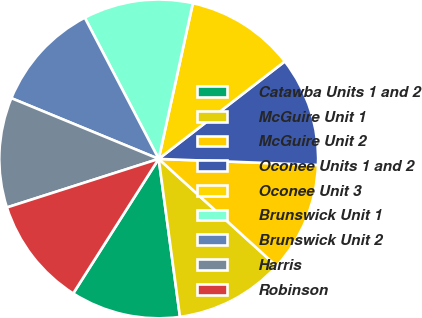<chart> <loc_0><loc_0><loc_500><loc_500><pie_chart><fcel>Catawba Units 1 and 2<fcel>McGuire Unit 1<fcel>McGuire Unit 2<fcel>Oconee Units 1 and 2<fcel>Oconee Unit 3<fcel>Brunswick Unit 1<fcel>Brunswick Unit 2<fcel>Harris<fcel>Robinson<nl><fcel>11.14%<fcel>11.12%<fcel>11.14%<fcel>11.08%<fcel>11.09%<fcel>11.11%<fcel>11.1%<fcel>11.15%<fcel>11.06%<nl></chart> 